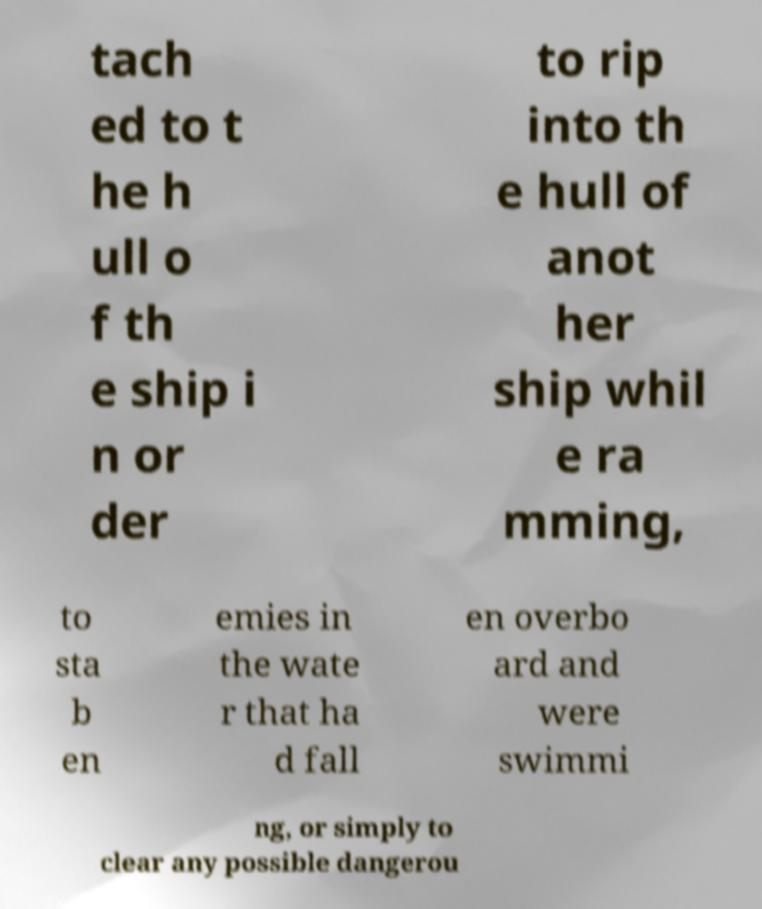Could you extract and type out the text from this image? tach ed to t he h ull o f th e ship i n or der to rip into th e hull of anot her ship whil e ra mming, to sta b en emies in the wate r that ha d fall en overbo ard and were swimmi ng, or simply to clear any possible dangerou 